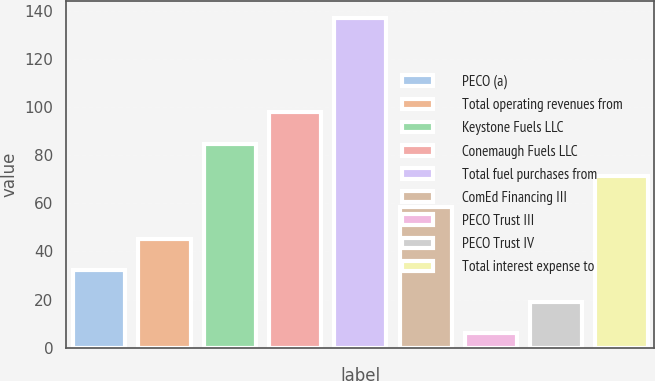Convert chart. <chart><loc_0><loc_0><loc_500><loc_500><bar_chart><fcel>PECO (a)<fcel>Total operating revenues from<fcel>Keystone Fuels LLC<fcel>Conemaugh Fuels LLC<fcel>Total fuel purchases from<fcel>ComEd Financing III<fcel>PECO Trust III<fcel>PECO Trust IV<fcel>Total interest expense to<nl><fcel>32.2<fcel>45.3<fcel>84.6<fcel>97.7<fcel>137<fcel>58.4<fcel>6<fcel>19.1<fcel>71.5<nl></chart> 